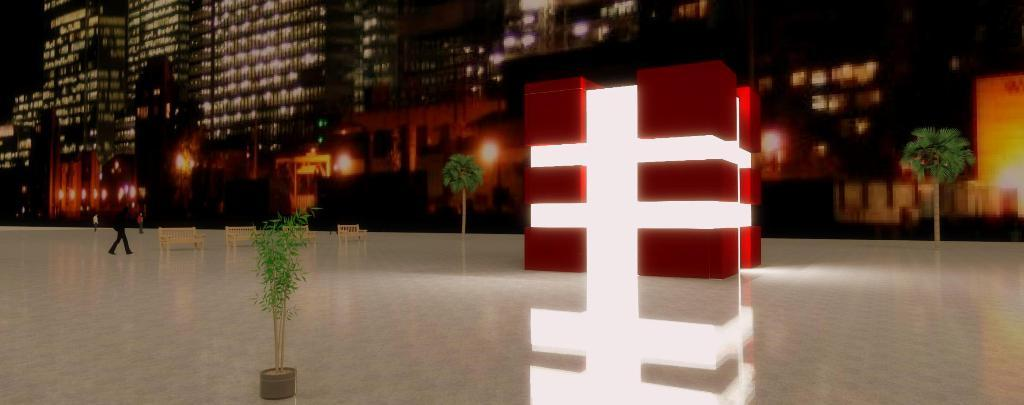What is the main subject of the image? The main subject of the image is the many buildings. What is located in front of the buildings? There is a floor in front of the buildings. What are people doing on the floor? People are walking on the floor. What type of seating is available on the floor? There are benches on the floor. Can you describe an unusual object in the image? There is a lighted cube in the image. What type of badge is being discussed at the meeting in the image? There is no meeting or badge present in the image; it features buildings, a floor, people walking, benches, and a lighted cube. How many lights are there on the lighted cube in the image? The number of lights on the lighted cube cannot be determined from the image alone, as it only shows the presence of a lighted cube without specifying the number of lights. 